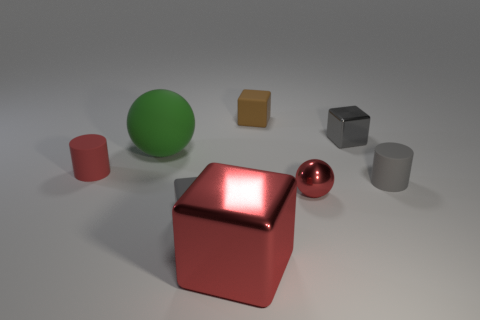How many other objects are the same size as the gray shiny block?
Offer a very short reply. 5. Is the matte ball the same color as the tiny metal cube?
Ensure brevity in your answer.  No. What is the shape of the small gray object that is behind the red object that is on the left side of the gray cube that is in front of the red ball?
Make the answer very short. Cube. What number of things are tiny gray rubber things left of the big red metallic block or objects right of the large metallic thing?
Make the answer very short. 5. There is a matte cube on the left side of the brown cube behind the small gray metallic thing; what size is it?
Offer a very short reply. Small. Is the color of the matte block behind the green sphere the same as the large metal cube?
Keep it short and to the point. No. Are there any large green matte objects of the same shape as the large red metal object?
Offer a very short reply. No. What is the color of the cube that is the same size as the green matte thing?
Offer a very short reply. Red. What size is the cylinder that is on the right side of the brown block?
Your response must be concise. Small. Are there any matte objects to the left of the gray block that is left of the brown rubber object?
Offer a very short reply. Yes. 